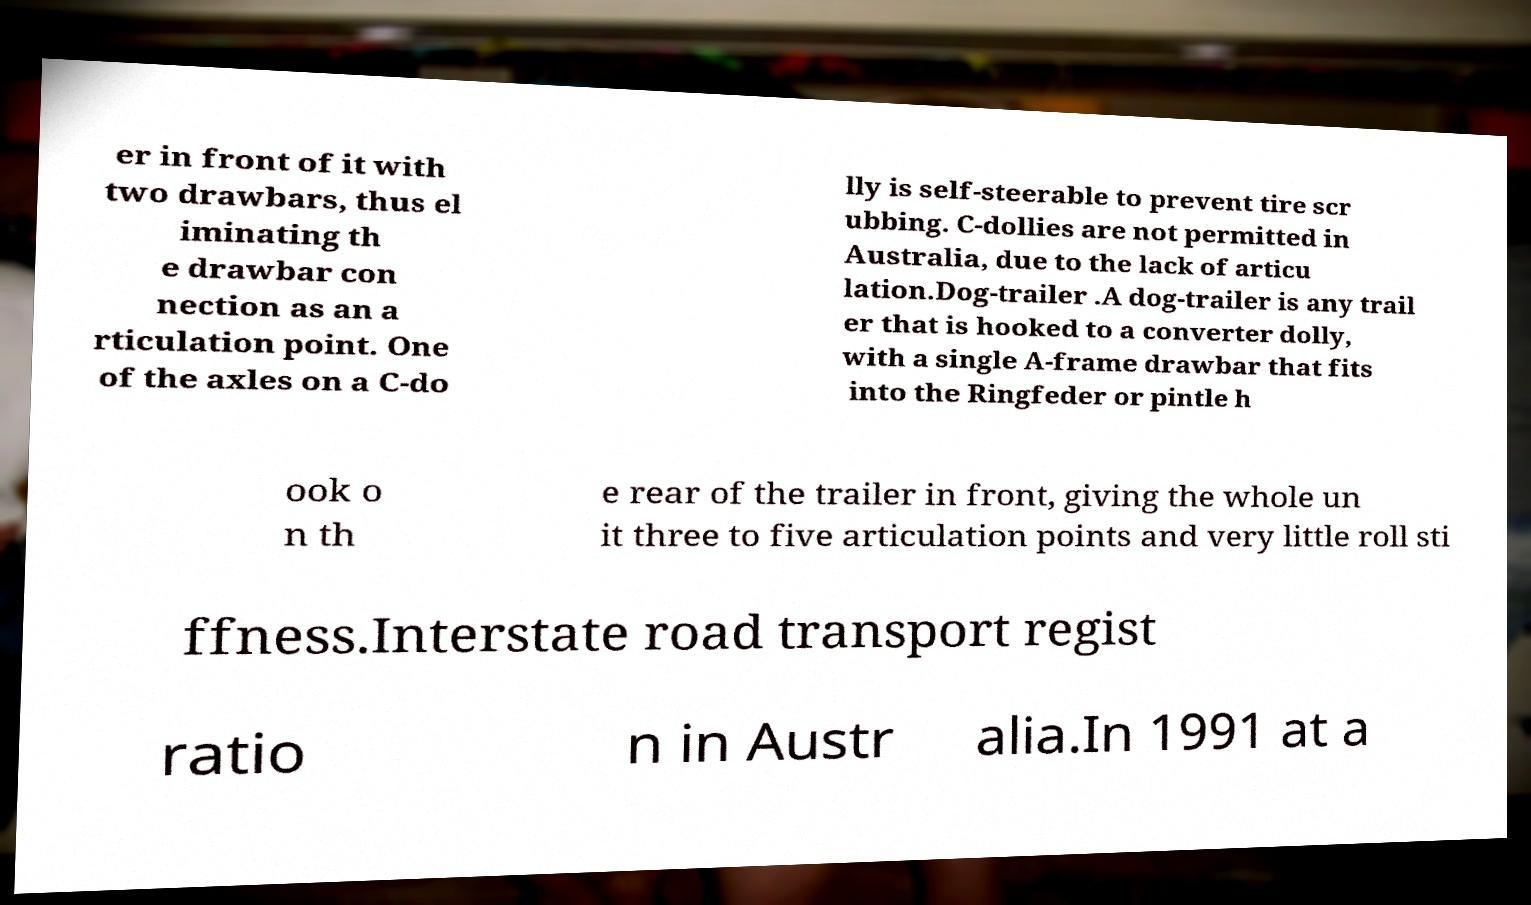Could you extract and type out the text from this image? er in front of it with two drawbars, thus el iminating th e drawbar con nection as an a rticulation point. One of the axles on a C-do lly is self-steerable to prevent tire scr ubbing. C-dollies are not permitted in Australia, due to the lack of articu lation.Dog-trailer .A dog-trailer is any trail er that is hooked to a converter dolly, with a single A-frame drawbar that fits into the Ringfeder or pintle h ook o n th e rear of the trailer in front, giving the whole un it three to five articulation points and very little roll sti ffness.Interstate road transport regist ratio n in Austr alia.In 1991 at a 